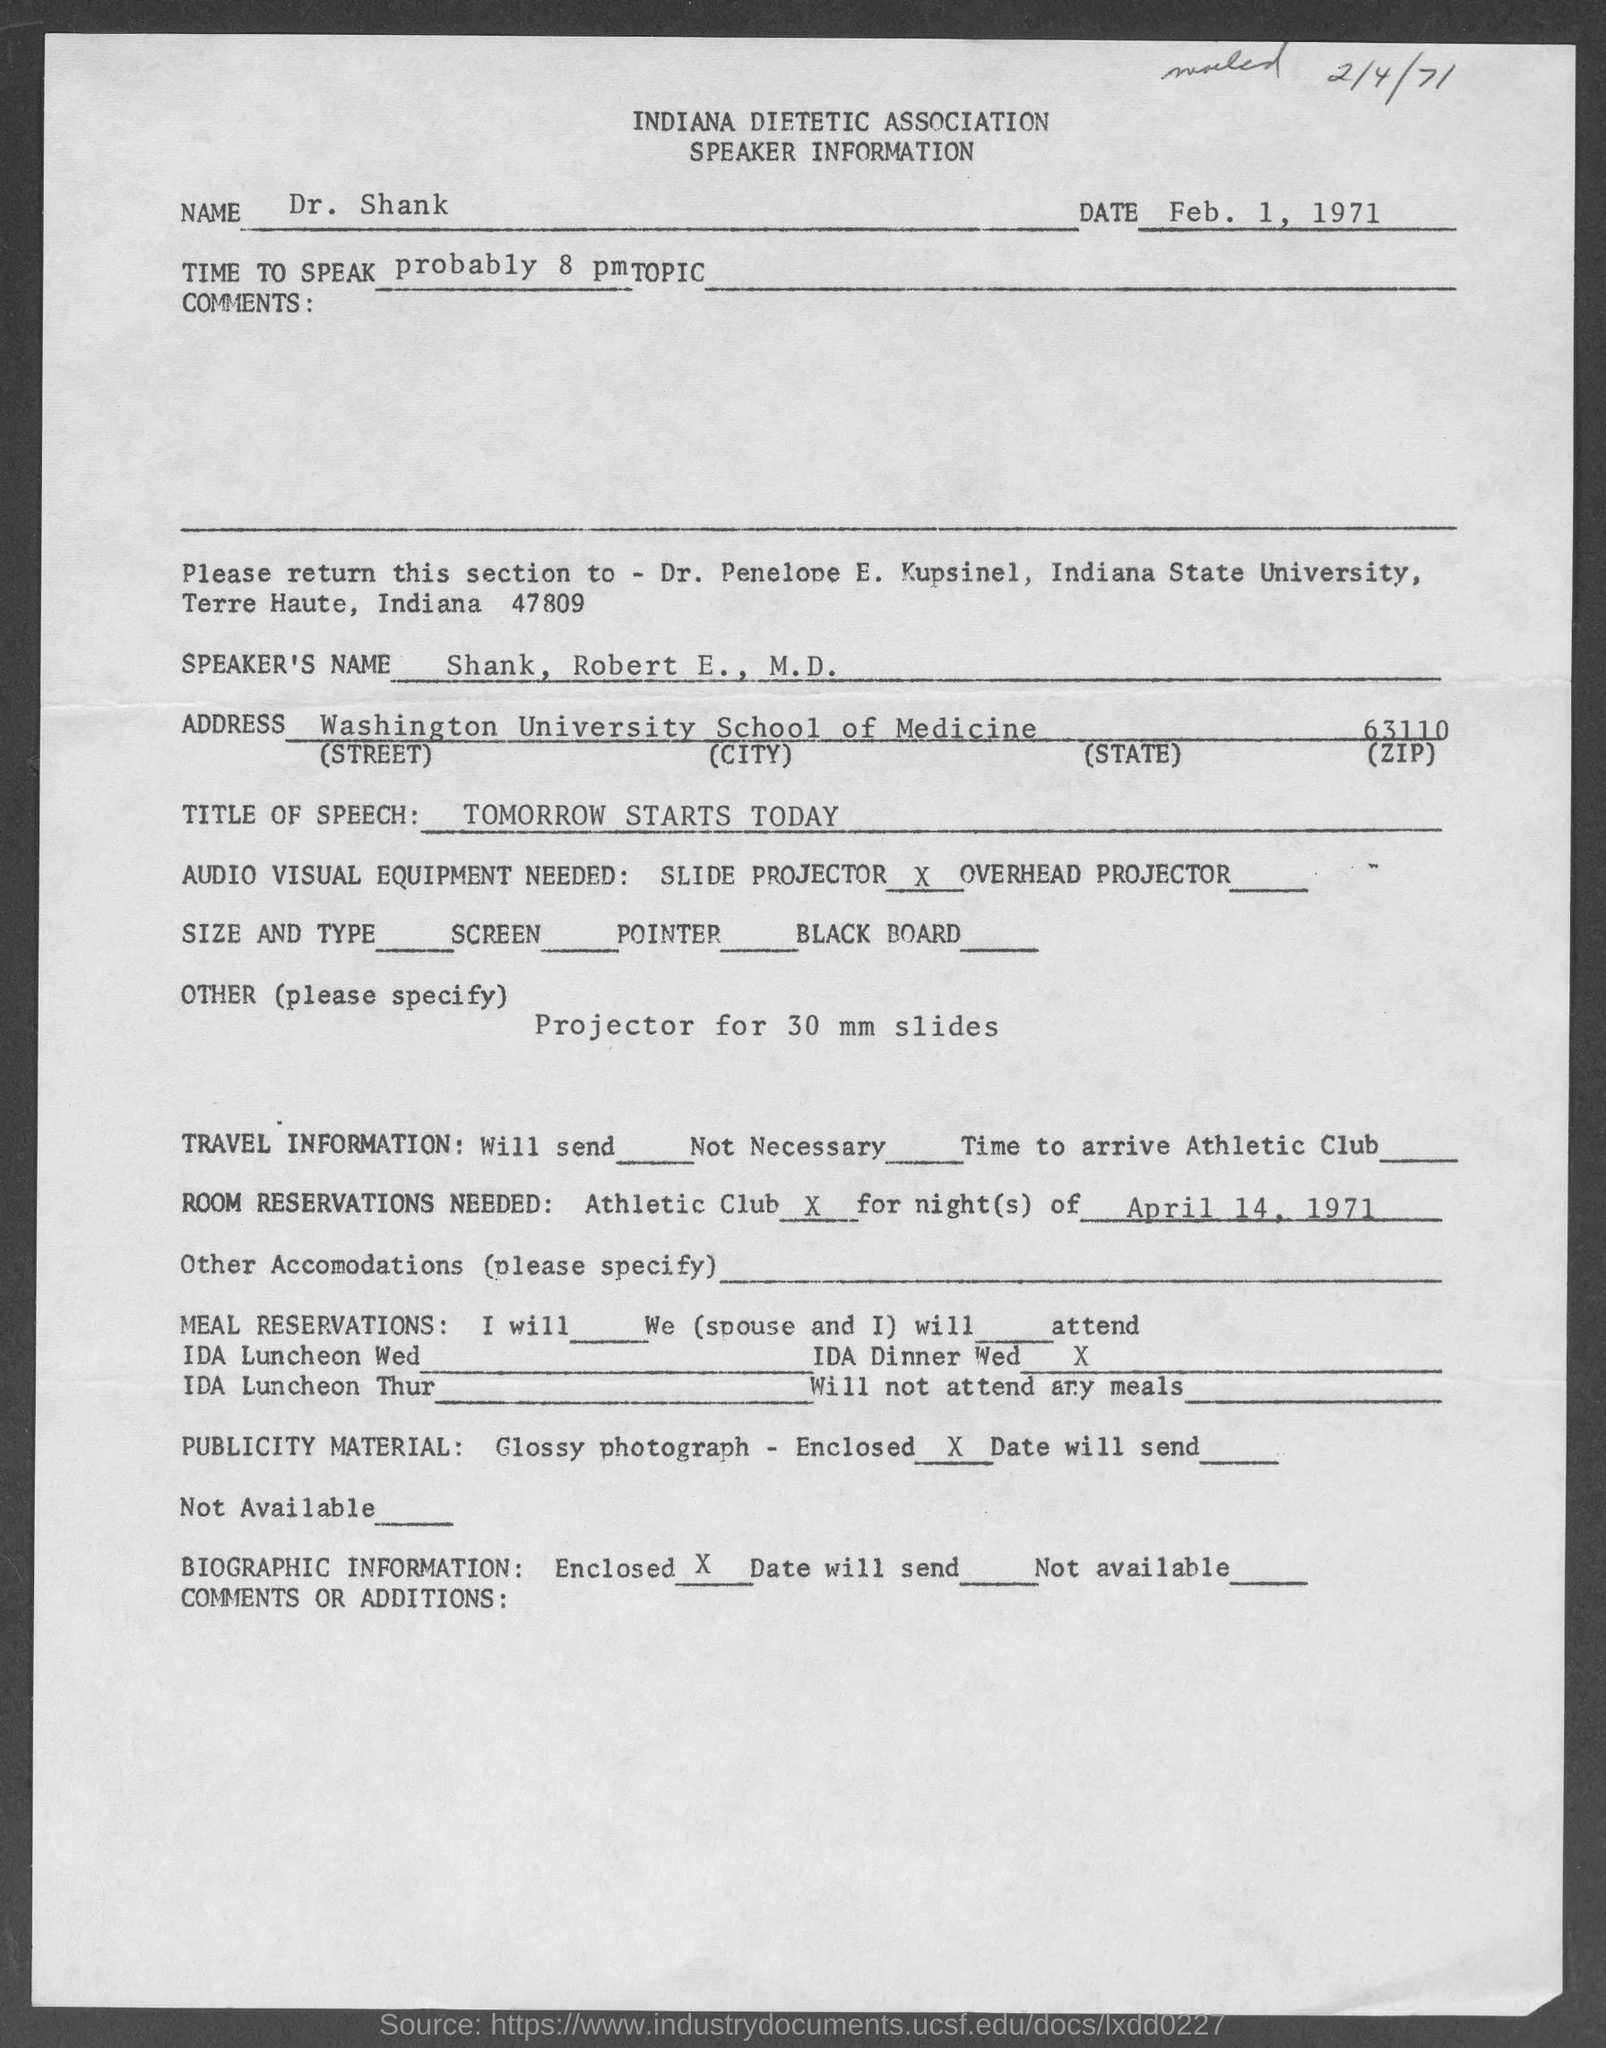Outline some significant characteristics in this image. The title of the speech is 'Tomorrow Starts Today.' The zip code is 63110. Indiana State University is located in the state of Indiana. 